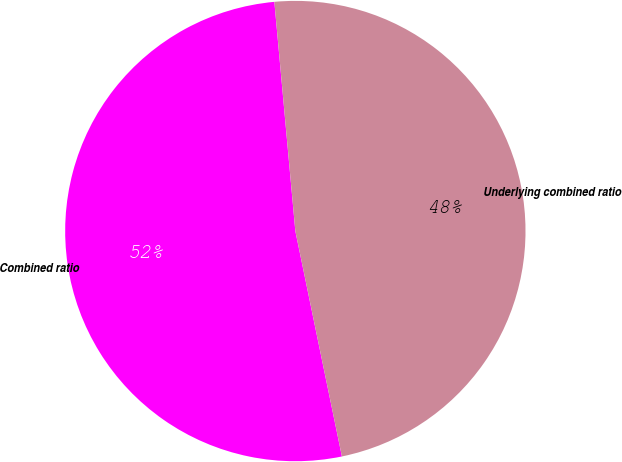Convert chart. <chart><loc_0><loc_0><loc_500><loc_500><pie_chart><fcel>Combined ratio<fcel>Underlying combined ratio<nl><fcel>51.79%<fcel>48.21%<nl></chart> 